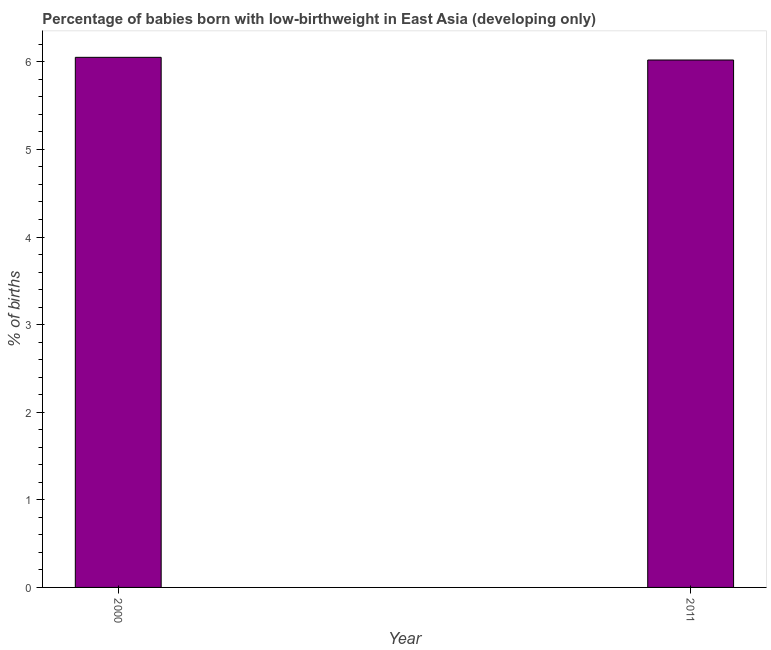Does the graph contain grids?
Keep it short and to the point. No. What is the title of the graph?
Make the answer very short. Percentage of babies born with low-birthweight in East Asia (developing only). What is the label or title of the X-axis?
Offer a terse response. Year. What is the label or title of the Y-axis?
Offer a terse response. % of births. What is the percentage of babies who were born with low-birthweight in 2011?
Make the answer very short. 6.02. Across all years, what is the maximum percentage of babies who were born with low-birthweight?
Offer a very short reply. 6.05. Across all years, what is the minimum percentage of babies who were born with low-birthweight?
Your answer should be very brief. 6.02. What is the sum of the percentage of babies who were born with low-birthweight?
Your answer should be compact. 12.07. What is the difference between the percentage of babies who were born with low-birthweight in 2000 and 2011?
Ensure brevity in your answer.  0.03. What is the average percentage of babies who were born with low-birthweight per year?
Offer a terse response. 6.04. What is the median percentage of babies who were born with low-birthweight?
Ensure brevity in your answer.  6.04. In how many years, is the percentage of babies who were born with low-birthweight greater than 4 %?
Provide a succinct answer. 2. Do a majority of the years between 2000 and 2011 (inclusive) have percentage of babies who were born with low-birthweight greater than 1.2 %?
Give a very brief answer. Yes. What is the ratio of the percentage of babies who were born with low-birthweight in 2000 to that in 2011?
Ensure brevity in your answer.  1. Is the percentage of babies who were born with low-birthweight in 2000 less than that in 2011?
Offer a terse response. No. In how many years, is the percentage of babies who were born with low-birthweight greater than the average percentage of babies who were born with low-birthweight taken over all years?
Ensure brevity in your answer.  1. How many bars are there?
Offer a terse response. 2. What is the % of births in 2000?
Ensure brevity in your answer.  6.05. What is the % of births of 2011?
Offer a very short reply. 6.02. What is the difference between the % of births in 2000 and 2011?
Provide a succinct answer. 0.03. What is the ratio of the % of births in 2000 to that in 2011?
Your answer should be compact. 1. 